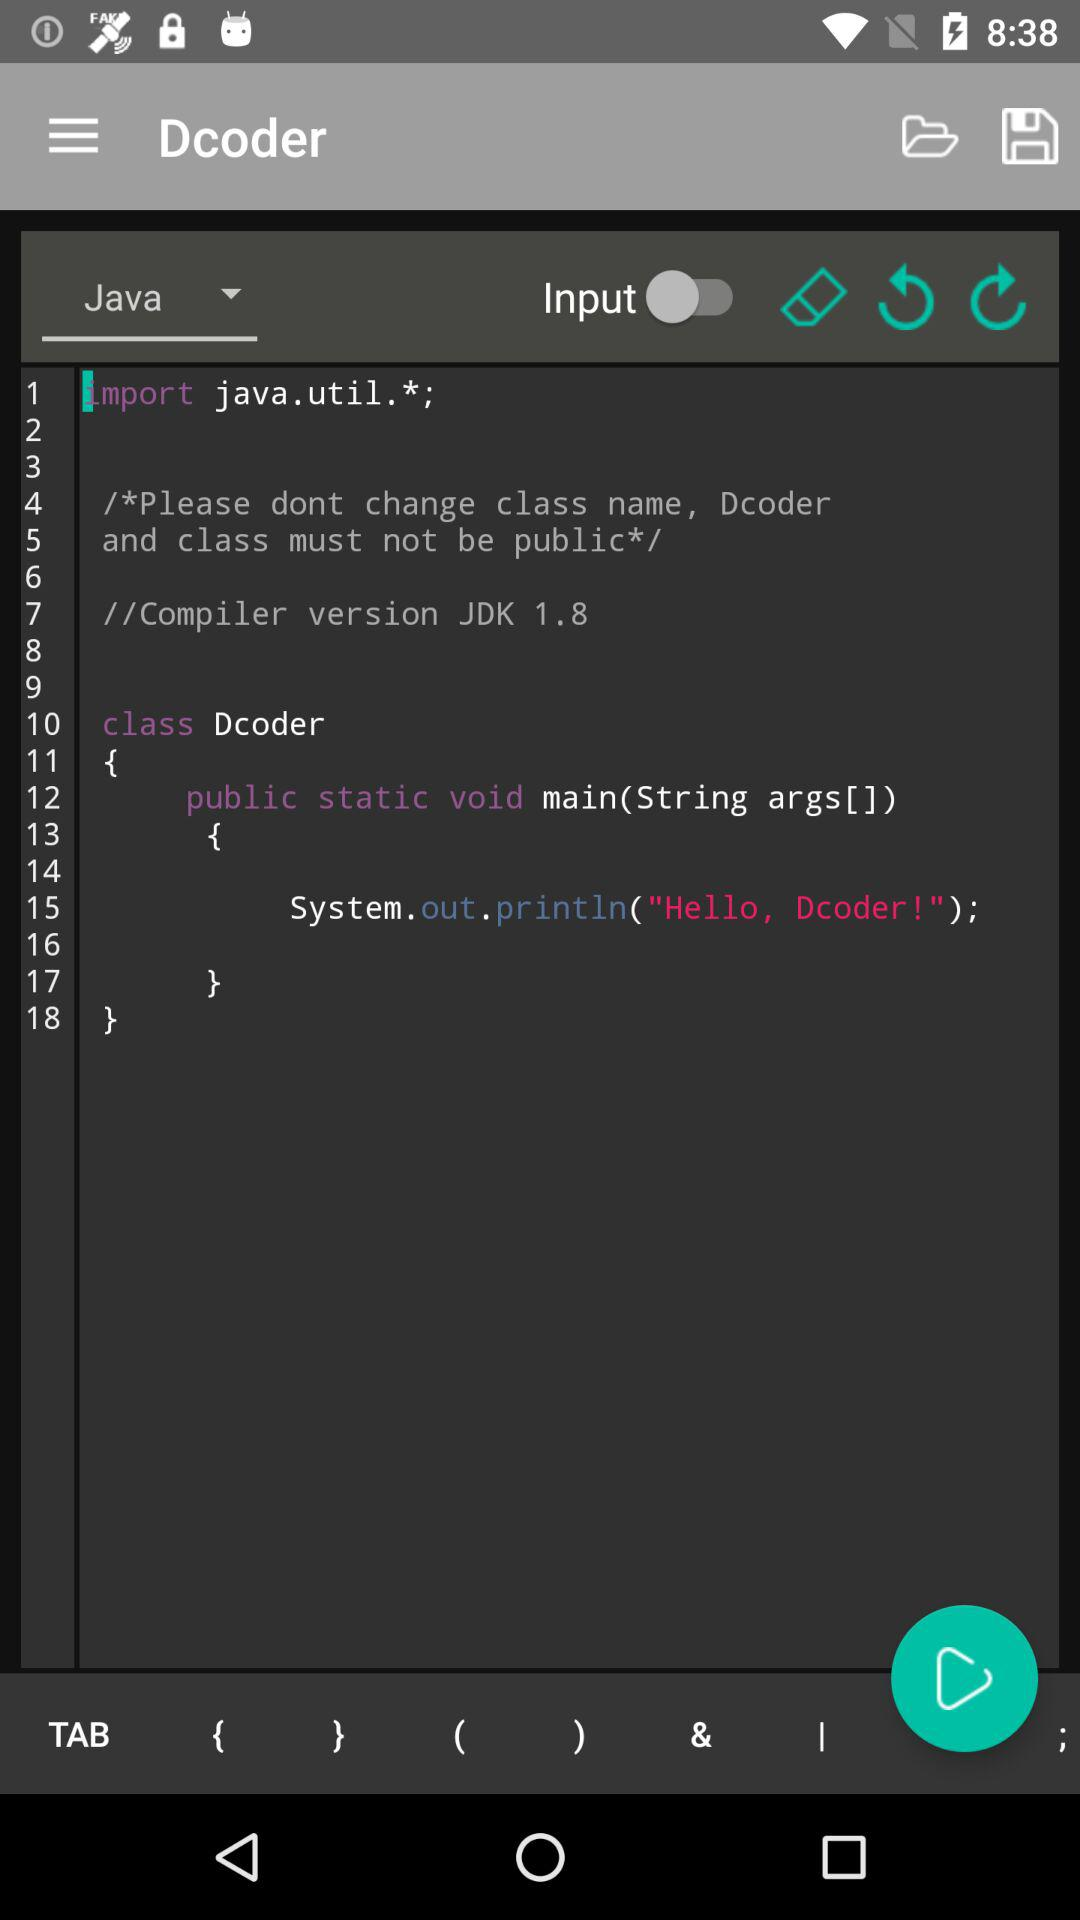How many lines of code are there in the file?
Answer the question using a single word or phrase. 18 